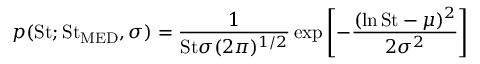Convert formula to latex. <formula><loc_0><loc_0><loc_500><loc_500>p ( S t ; S t _ { M E D } , \sigma ) = \frac { 1 } { S t \sigma ( 2 \pi ) ^ { 1 / 2 } } \exp \left [ - \frac { ( \ln S t - \mu ) ^ { 2 } } { 2 \sigma ^ { 2 } } \right ]</formula> 